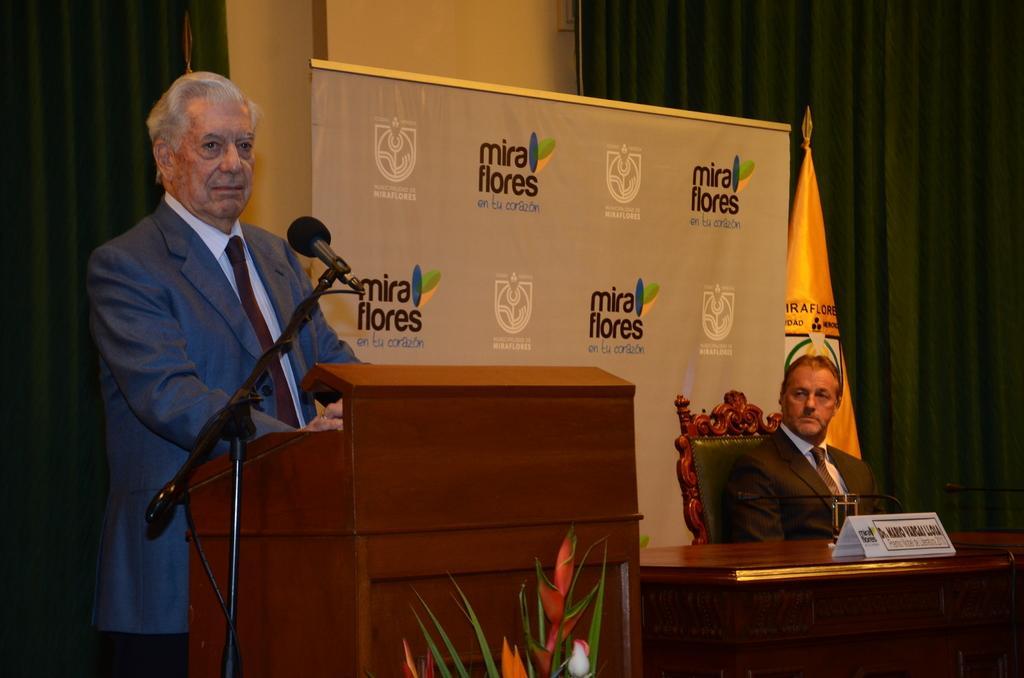Describe this image in one or two sentences. There is a Mic on the right side of this image and there is one person standing beside to this Mic is wearing a blazer. There is one other person sitting on the chair is on the right side of this image. There is a flag and a poster in the middle of this image. There is a wall in the background. As we can see there is a curtain on the left side of this image and right side of this image as well. 